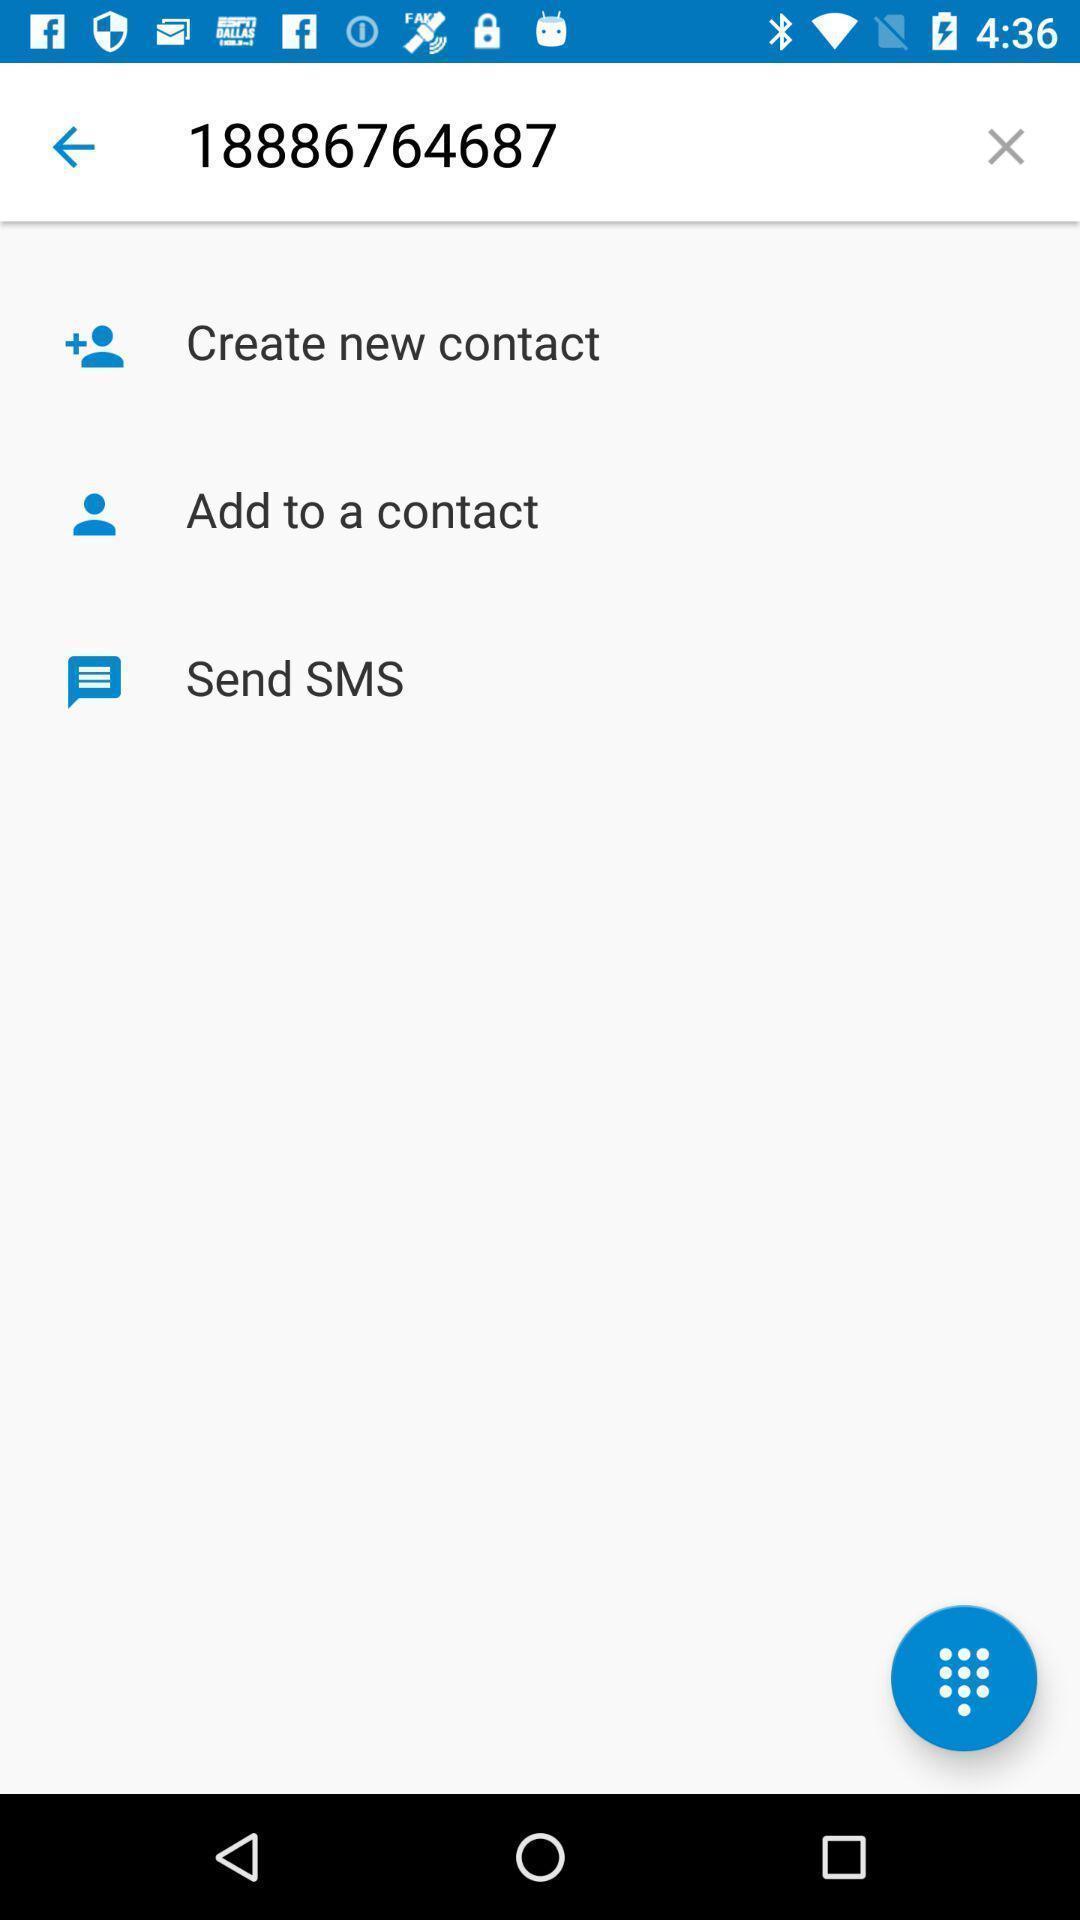Give me a narrative description of this picture. Social app for doing messages and calling. 